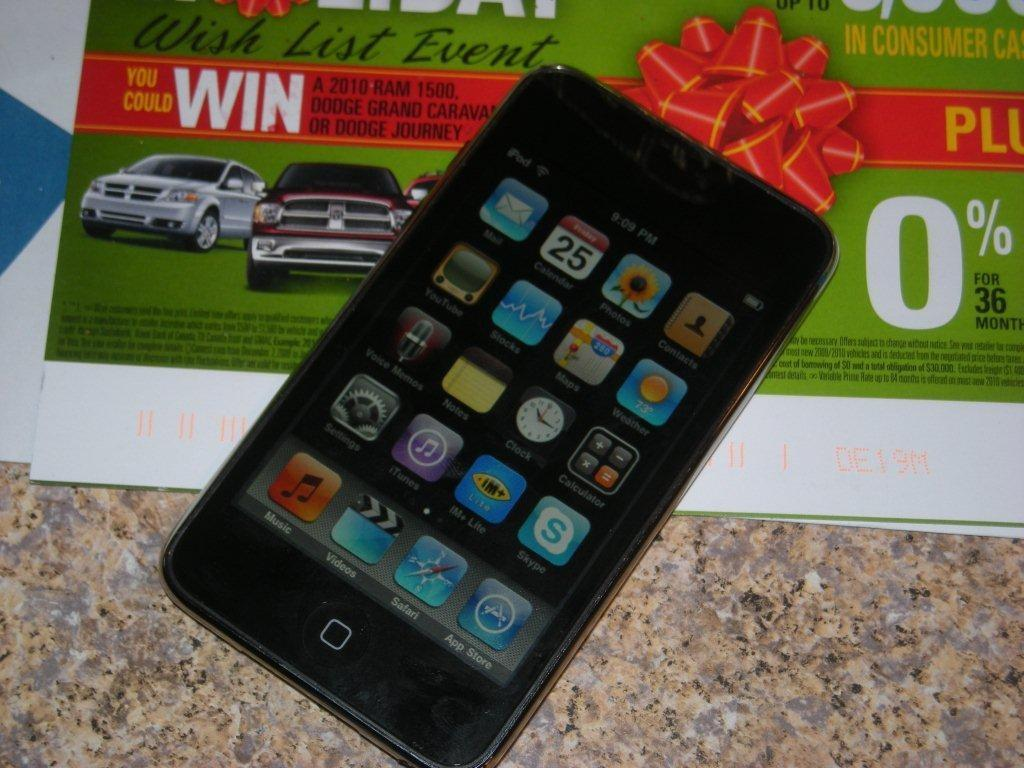What electronic device is present in the image? There is a phone in the image. What can be seen on the phone's screen? The phone's apps are visible in the image. What is located on the floor in the image? There is a paper on the floor. What type of oil is being used to punish the cattle in the image? There is no oil, punishment, or cattle present in the image. 